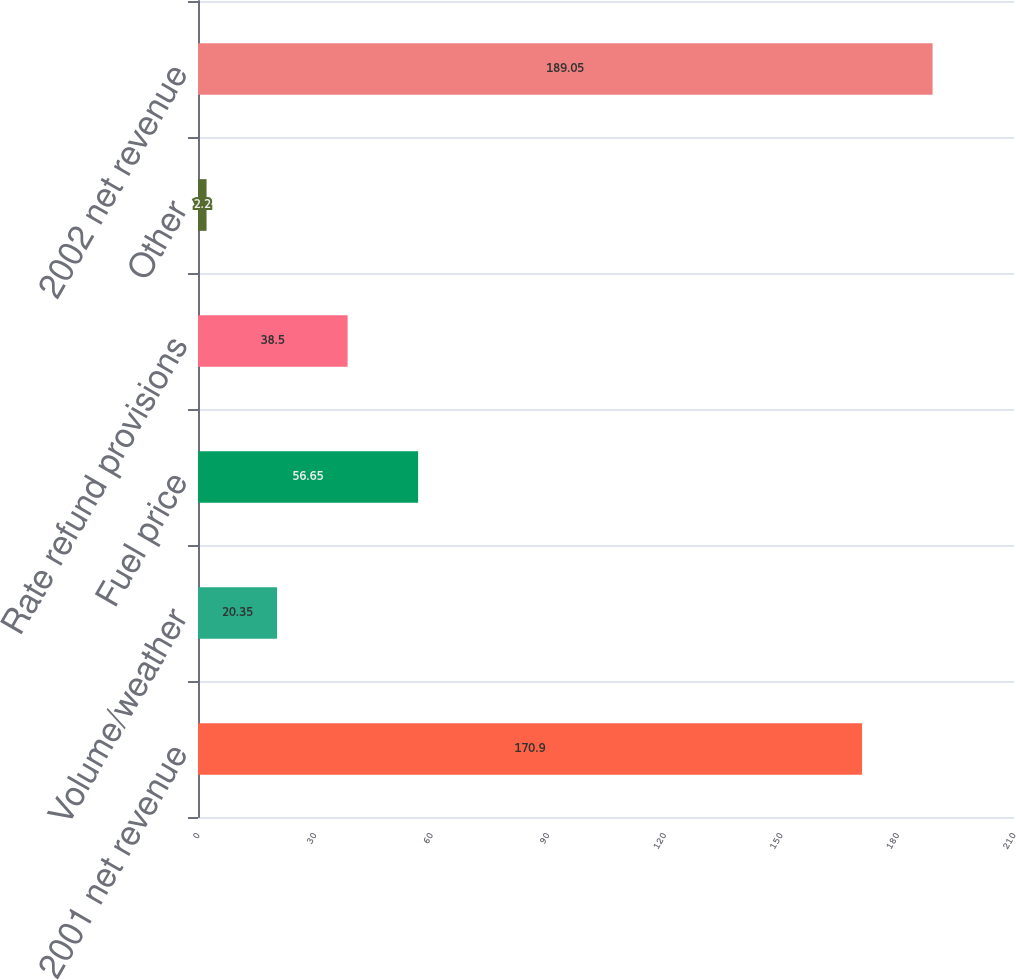Convert chart. <chart><loc_0><loc_0><loc_500><loc_500><bar_chart><fcel>2001 net revenue<fcel>Volume/weather<fcel>Fuel price<fcel>Rate refund provisions<fcel>Other<fcel>2002 net revenue<nl><fcel>170.9<fcel>20.35<fcel>56.65<fcel>38.5<fcel>2.2<fcel>189.05<nl></chart> 